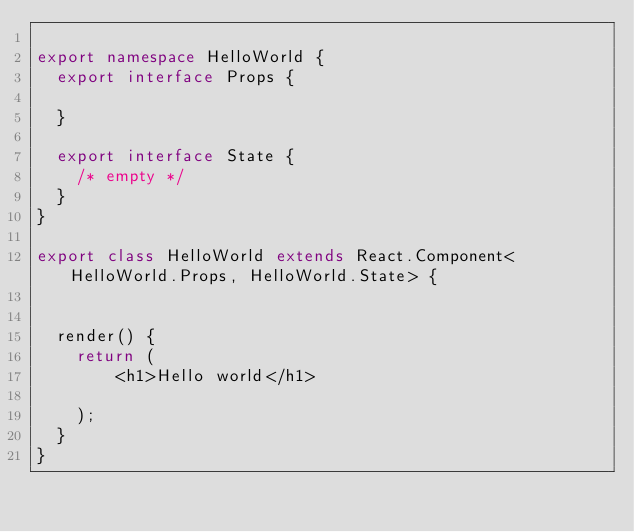Convert code to text. <code><loc_0><loc_0><loc_500><loc_500><_TypeScript_>
export namespace HelloWorld {
  export interface Props {
    
  }

  export interface State {
    /* empty */
  }
}

export class HelloWorld extends React.Component<HelloWorld.Props, HelloWorld.State> { 
 

  render() {
    return (     
        <h1>Hello world</h1>      
  
    );
  }
}


</code> 